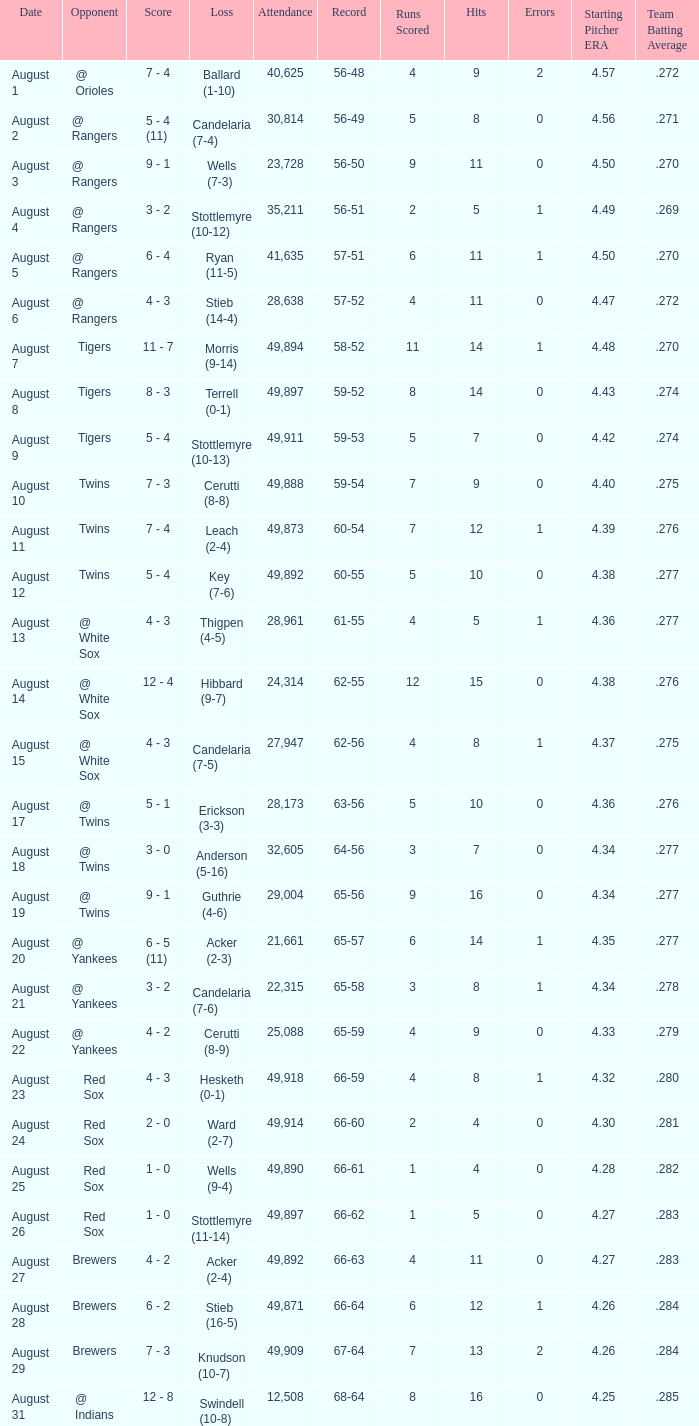What was the Attendance high on August 28? 49871.0. 